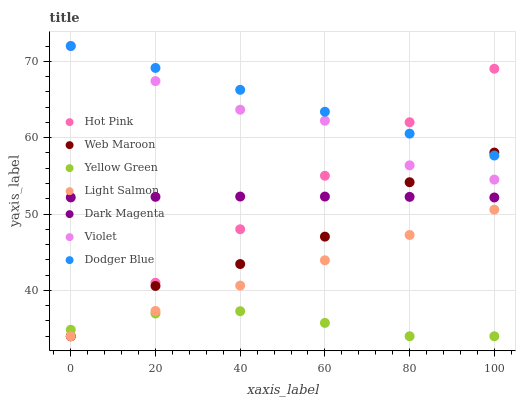Does Yellow Green have the minimum area under the curve?
Answer yes or no. Yes. Does Dodger Blue have the maximum area under the curve?
Answer yes or no. Yes. Does Hot Pink have the minimum area under the curve?
Answer yes or no. No. Does Hot Pink have the maximum area under the curve?
Answer yes or no. No. Is Light Salmon the smoothest?
Answer yes or no. Yes. Is Violet the roughest?
Answer yes or no. Yes. Is Yellow Green the smoothest?
Answer yes or no. No. Is Yellow Green the roughest?
Answer yes or no. No. Does Light Salmon have the lowest value?
Answer yes or no. Yes. Does Dodger Blue have the lowest value?
Answer yes or no. No. Does Violet have the highest value?
Answer yes or no. Yes. Does Hot Pink have the highest value?
Answer yes or no. No. Is Light Salmon less than Violet?
Answer yes or no. Yes. Is Dark Magenta greater than Yellow Green?
Answer yes or no. Yes. Does Dodger Blue intersect Web Maroon?
Answer yes or no. Yes. Is Dodger Blue less than Web Maroon?
Answer yes or no. No. Is Dodger Blue greater than Web Maroon?
Answer yes or no. No. Does Light Salmon intersect Violet?
Answer yes or no. No. 